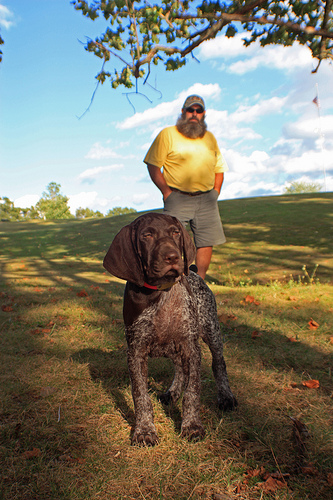Please provide a short description for this region: [0.52, 0.24, 0.59, 0.28]. The region shows the face of an elder man with a full, textured grey beard, appearing thoughtful. 